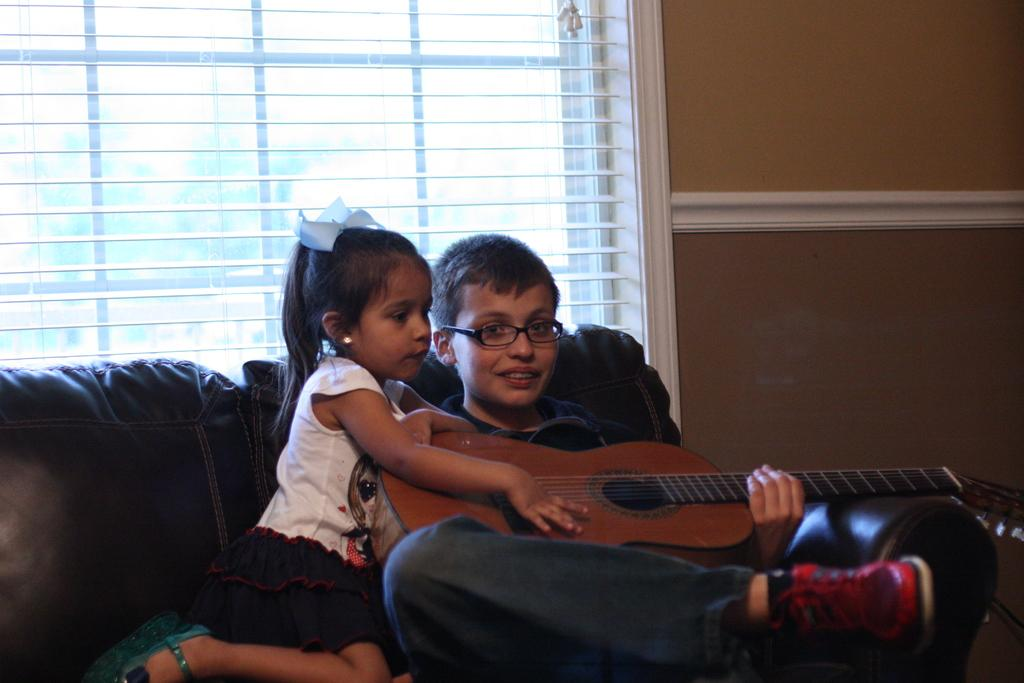Who are the people in the image? There is a boy and a girl in the image. What are the boy and girl doing in the image? The boy and girl are sitting on a sofa and holding guitars. Can you describe the setting of the image? There is a window visible in the image. What type of cow can be seen participating in the competition in the image? There is no cow or competition present in the image; it features a boy and a girl sitting on a sofa and holding guitars. Can you tell me what the dad of the boy is doing in the image? There is no dad present in the image, only the boy and girl are visible. 